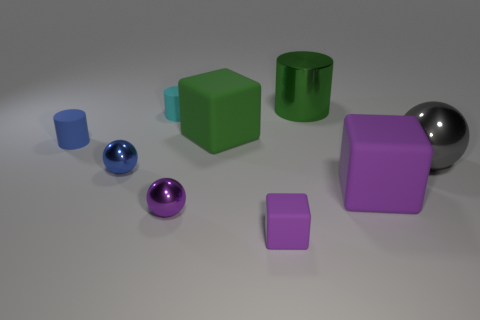Subtract all small cubes. How many cubes are left? 2 Subtract all cyan cylinders. How many purple blocks are left? 2 Subtract 1 spheres. How many spheres are left? 2 Add 1 small purple matte objects. How many objects exist? 10 Subtract all cyan blocks. Subtract all red cylinders. How many blocks are left? 3 Subtract all small brown cubes. Subtract all big gray shiny balls. How many objects are left? 8 Add 3 small blue spheres. How many small blue spheres are left? 4 Add 9 large yellow rubber cylinders. How many large yellow rubber cylinders exist? 9 Subtract 1 green blocks. How many objects are left? 8 Subtract all spheres. How many objects are left? 6 